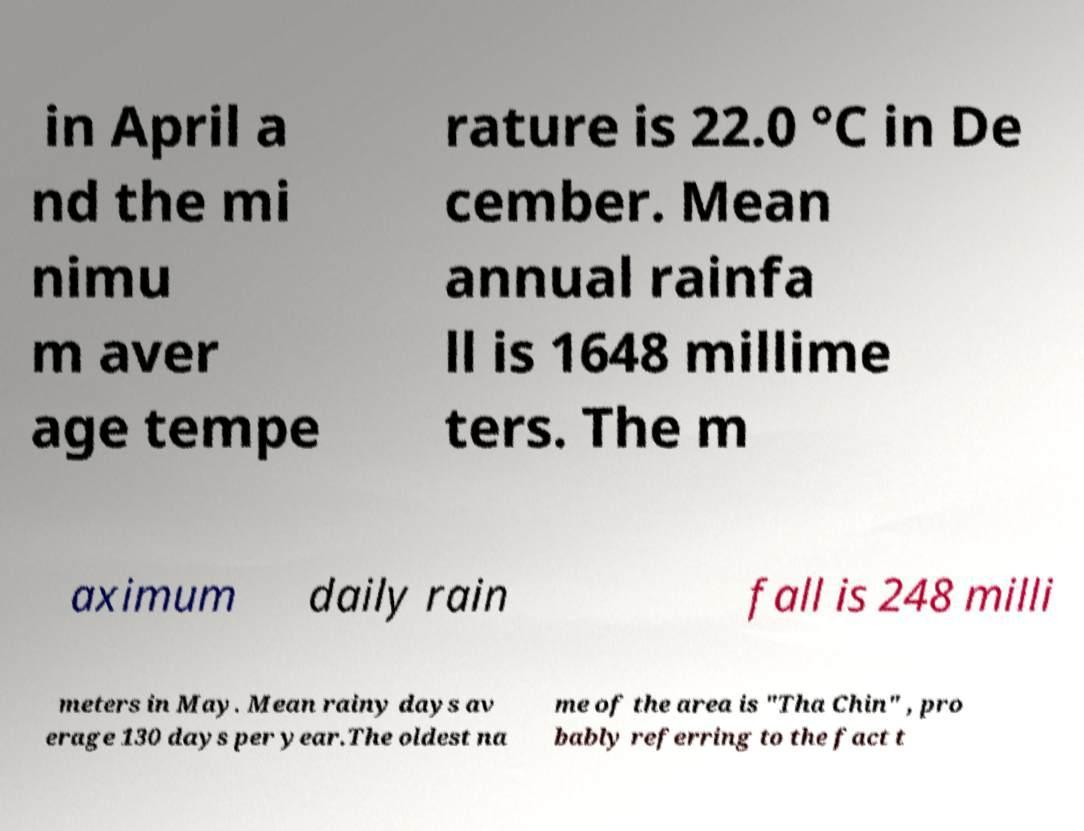Please identify and transcribe the text found in this image. in April a nd the mi nimu m aver age tempe rature is 22.0 °C in De cember. Mean annual rainfa ll is 1648 millime ters. The m aximum daily rain fall is 248 milli meters in May. Mean rainy days av erage 130 days per year.The oldest na me of the area is "Tha Chin" , pro bably referring to the fact t 